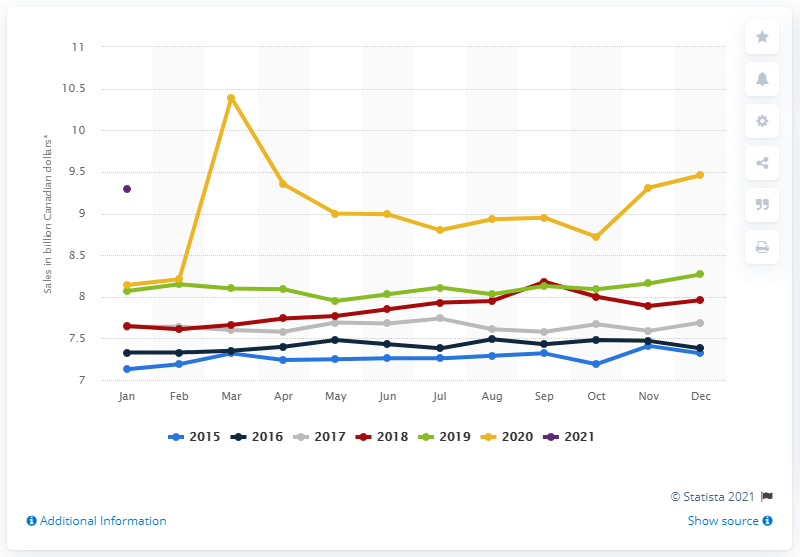List a handful of essential elements in this visual. In January 2021, the monthly sales of grocery stores in Canada were 9.31. In March 2020, the sales of grocery stores increased by 10.39% compared to the previous month. In March 2020, the monthly sales of grocery stores in Canada were 10.39... 